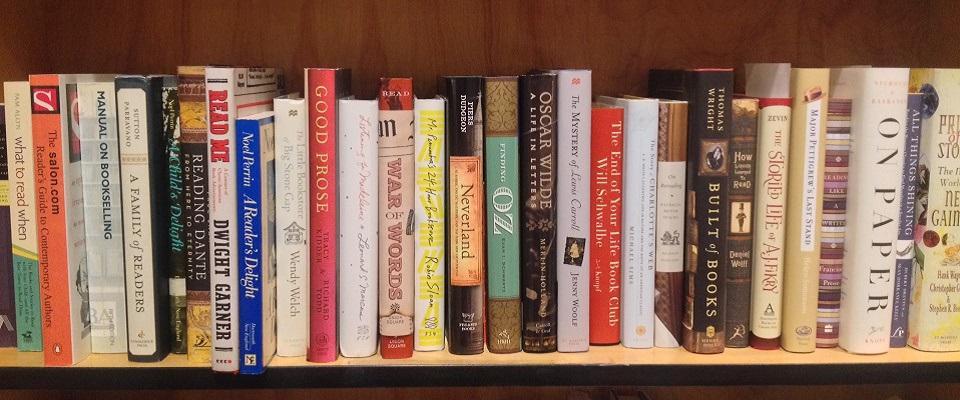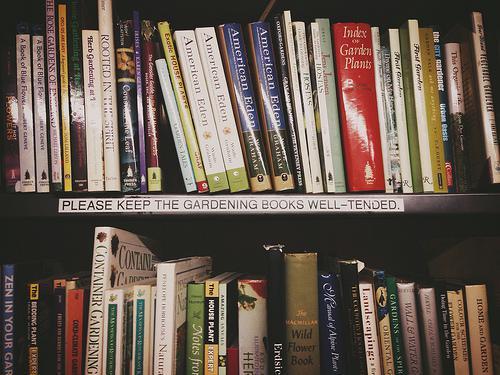The first image is the image on the left, the second image is the image on the right. Examine the images to the left and right. Is the description "The right image shows at least one book withe its pages splayed open." accurate? Answer yes or no. No. The first image is the image on the left, the second image is the image on the right. Considering the images on both sides, is "there are open books laying next to a stack of 6 books next to it" valid? Answer yes or no. No. 